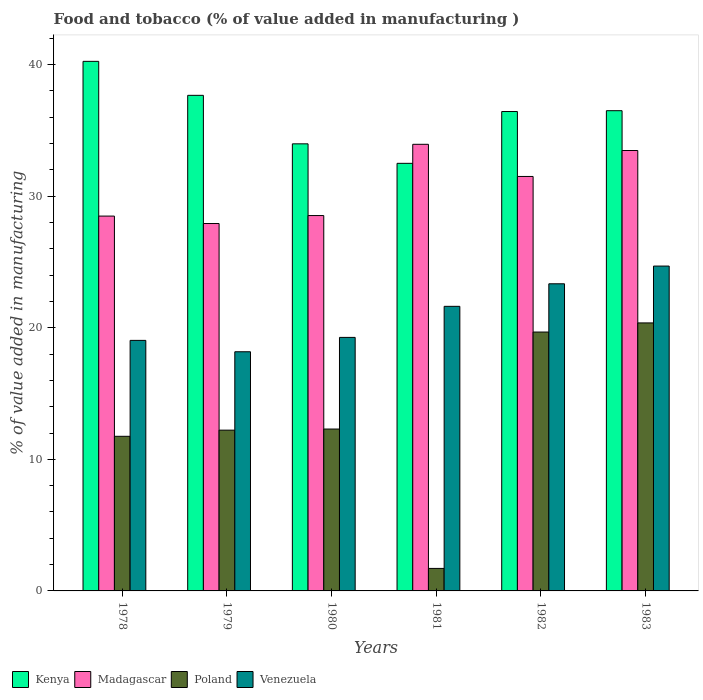How many groups of bars are there?
Keep it short and to the point. 6. Are the number of bars per tick equal to the number of legend labels?
Your answer should be compact. Yes. How many bars are there on the 6th tick from the left?
Make the answer very short. 4. What is the label of the 4th group of bars from the left?
Keep it short and to the point. 1981. In how many cases, is the number of bars for a given year not equal to the number of legend labels?
Your answer should be compact. 0. What is the value added in manufacturing food and tobacco in Kenya in 1982?
Your answer should be very brief. 36.43. Across all years, what is the maximum value added in manufacturing food and tobacco in Kenya?
Your answer should be compact. 40.25. Across all years, what is the minimum value added in manufacturing food and tobacco in Poland?
Offer a very short reply. 1.71. In which year was the value added in manufacturing food and tobacco in Kenya maximum?
Provide a short and direct response. 1978. In which year was the value added in manufacturing food and tobacco in Poland minimum?
Your answer should be compact. 1981. What is the total value added in manufacturing food and tobacco in Venezuela in the graph?
Ensure brevity in your answer.  126.14. What is the difference between the value added in manufacturing food and tobacco in Venezuela in 1978 and that in 1983?
Provide a succinct answer. -5.65. What is the difference between the value added in manufacturing food and tobacco in Venezuela in 1981 and the value added in manufacturing food and tobacco in Kenya in 1980?
Provide a succinct answer. -12.35. What is the average value added in manufacturing food and tobacco in Madagascar per year?
Your response must be concise. 30.64. In the year 1978, what is the difference between the value added in manufacturing food and tobacco in Kenya and value added in manufacturing food and tobacco in Poland?
Your answer should be very brief. 28.5. What is the ratio of the value added in manufacturing food and tobacco in Madagascar in 1978 to that in 1980?
Keep it short and to the point. 1. Is the value added in manufacturing food and tobacco in Poland in 1979 less than that in 1980?
Provide a succinct answer. Yes. What is the difference between the highest and the second highest value added in manufacturing food and tobacco in Kenya?
Offer a terse response. 2.58. What is the difference between the highest and the lowest value added in manufacturing food and tobacco in Madagascar?
Give a very brief answer. 6.02. Is it the case that in every year, the sum of the value added in manufacturing food and tobacco in Poland and value added in manufacturing food and tobacco in Venezuela is greater than the sum of value added in manufacturing food and tobacco in Madagascar and value added in manufacturing food and tobacco in Kenya?
Your response must be concise. Yes. What does the 4th bar from the left in 1979 represents?
Provide a succinct answer. Venezuela. What does the 2nd bar from the right in 1982 represents?
Your answer should be very brief. Poland. Is it the case that in every year, the sum of the value added in manufacturing food and tobacco in Madagascar and value added in manufacturing food and tobacco in Kenya is greater than the value added in manufacturing food and tobacco in Poland?
Offer a terse response. Yes. Are the values on the major ticks of Y-axis written in scientific E-notation?
Offer a very short reply. No. How many legend labels are there?
Provide a short and direct response. 4. How are the legend labels stacked?
Offer a terse response. Horizontal. What is the title of the graph?
Your response must be concise. Food and tobacco (% of value added in manufacturing ). What is the label or title of the Y-axis?
Make the answer very short. % of value added in manufacturing. What is the % of value added in manufacturing in Kenya in 1978?
Make the answer very short. 40.25. What is the % of value added in manufacturing of Madagascar in 1978?
Your answer should be compact. 28.49. What is the % of value added in manufacturing in Poland in 1978?
Your answer should be compact. 11.75. What is the % of value added in manufacturing in Venezuela in 1978?
Your answer should be very brief. 19.04. What is the % of value added in manufacturing of Kenya in 1979?
Your response must be concise. 37.66. What is the % of value added in manufacturing of Madagascar in 1979?
Keep it short and to the point. 27.92. What is the % of value added in manufacturing in Poland in 1979?
Your answer should be very brief. 12.22. What is the % of value added in manufacturing in Venezuela in 1979?
Offer a terse response. 18.18. What is the % of value added in manufacturing in Kenya in 1980?
Your answer should be compact. 33.98. What is the % of value added in manufacturing in Madagascar in 1980?
Keep it short and to the point. 28.53. What is the % of value added in manufacturing in Poland in 1980?
Give a very brief answer. 12.3. What is the % of value added in manufacturing in Venezuela in 1980?
Your response must be concise. 19.27. What is the % of value added in manufacturing in Kenya in 1981?
Your response must be concise. 32.5. What is the % of value added in manufacturing of Madagascar in 1981?
Provide a short and direct response. 33.94. What is the % of value added in manufacturing of Poland in 1981?
Ensure brevity in your answer.  1.71. What is the % of value added in manufacturing in Venezuela in 1981?
Your answer should be very brief. 21.63. What is the % of value added in manufacturing in Kenya in 1982?
Ensure brevity in your answer.  36.43. What is the % of value added in manufacturing of Madagascar in 1982?
Make the answer very short. 31.5. What is the % of value added in manufacturing in Poland in 1982?
Provide a succinct answer. 19.67. What is the % of value added in manufacturing in Venezuela in 1982?
Offer a very short reply. 23.34. What is the % of value added in manufacturing of Kenya in 1983?
Your answer should be compact. 36.5. What is the % of value added in manufacturing of Madagascar in 1983?
Your answer should be compact. 33.47. What is the % of value added in manufacturing in Poland in 1983?
Provide a short and direct response. 20.37. What is the % of value added in manufacturing in Venezuela in 1983?
Your answer should be compact. 24.69. Across all years, what is the maximum % of value added in manufacturing in Kenya?
Your answer should be compact. 40.25. Across all years, what is the maximum % of value added in manufacturing in Madagascar?
Keep it short and to the point. 33.94. Across all years, what is the maximum % of value added in manufacturing in Poland?
Your answer should be compact. 20.37. Across all years, what is the maximum % of value added in manufacturing of Venezuela?
Keep it short and to the point. 24.69. Across all years, what is the minimum % of value added in manufacturing of Kenya?
Your response must be concise. 32.5. Across all years, what is the minimum % of value added in manufacturing of Madagascar?
Give a very brief answer. 27.92. Across all years, what is the minimum % of value added in manufacturing in Poland?
Your response must be concise. 1.71. Across all years, what is the minimum % of value added in manufacturing of Venezuela?
Provide a succinct answer. 18.18. What is the total % of value added in manufacturing in Kenya in the graph?
Provide a short and direct response. 217.31. What is the total % of value added in manufacturing in Madagascar in the graph?
Give a very brief answer. 183.84. What is the total % of value added in manufacturing in Poland in the graph?
Your answer should be compact. 78.02. What is the total % of value added in manufacturing in Venezuela in the graph?
Give a very brief answer. 126.14. What is the difference between the % of value added in manufacturing in Kenya in 1978 and that in 1979?
Ensure brevity in your answer.  2.58. What is the difference between the % of value added in manufacturing of Madagascar in 1978 and that in 1979?
Your answer should be compact. 0.56. What is the difference between the % of value added in manufacturing of Poland in 1978 and that in 1979?
Provide a short and direct response. -0.47. What is the difference between the % of value added in manufacturing in Venezuela in 1978 and that in 1979?
Offer a very short reply. 0.86. What is the difference between the % of value added in manufacturing in Kenya in 1978 and that in 1980?
Give a very brief answer. 6.27. What is the difference between the % of value added in manufacturing in Madagascar in 1978 and that in 1980?
Offer a very short reply. -0.04. What is the difference between the % of value added in manufacturing in Poland in 1978 and that in 1980?
Keep it short and to the point. -0.55. What is the difference between the % of value added in manufacturing of Venezuela in 1978 and that in 1980?
Keep it short and to the point. -0.23. What is the difference between the % of value added in manufacturing in Kenya in 1978 and that in 1981?
Provide a short and direct response. 7.75. What is the difference between the % of value added in manufacturing of Madagascar in 1978 and that in 1981?
Provide a succinct answer. -5.46. What is the difference between the % of value added in manufacturing of Poland in 1978 and that in 1981?
Provide a short and direct response. 10.04. What is the difference between the % of value added in manufacturing of Venezuela in 1978 and that in 1981?
Your response must be concise. -2.59. What is the difference between the % of value added in manufacturing of Kenya in 1978 and that in 1982?
Provide a succinct answer. 3.81. What is the difference between the % of value added in manufacturing in Madagascar in 1978 and that in 1982?
Ensure brevity in your answer.  -3.01. What is the difference between the % of value added in manufacturing of Poland in 1978 and that in 1982?
Offer a terse response. -7.92. What is the difference between the % of value added in manufacturing of Venezuela in 1978 and that in 1982?
Offer a very short reply. -4.3. What is the difference between the % of value added in manufacturing of Kenya in 1978 and that in 1983?
Your answer should be compact. 3.75. What is the difference between the % of value added in manufacturing of Madagascar in 1978 and that in 1983?
Give a very brief answer. -4.98. What is the difference between the % of value added in manufacturing of Poland in 1978 and that in 1983?
Make the answer very short. -8.62. What is the difference between the % of value added in manufacturing of Venezuela in 1978 and that in 1983?
Provide a short and direct response. -5.65. What is the difference between the % of value added in manufacturing of Kenya in 1979 and that in 1980?
Make the answer very short. 3.69. What is the difference between the % of value added in manufacturing in Madagascar in 1979 and that in 1980?
Keep it short and to the point. -0.61. What is the difference between the % of value added in manufacturing in Poland in 1979 and that in 1980?
Your answer should be compact. -0.08. What is the difference between the % of value added in manufacturing in Venezuela in 1979 and that in 1980?
Your answer should be very brief. -1.09. What is the difference between the % of value added in manufacturing in Kenya in 1979 and that in 1981?
Ensure brevity in your answer.  5.17. What is the difference between the % of value added in manufacturing in Madagascar in 1979 and that in 1981?
Keep it short and to the point. -6.02. What is the difference between the % of value added in manufacturing in Poland in 1979 and that in 1981?
Your response must be concise. 10.51. What is the difference between the % of value added in manufacturing in Venezuela in 1979 and that in 1981?
Your answer should be very brief. -3.45. What is the difference between the % of value added in manufacturing in Kenya in 1979 and that in 1982?
Your answer should be compact. 1.23. What is the difference between the % of value added in manufacturing in Madagascar in 1979 and that in 1982?
Keep it short and to the point. -3.58. What is the difference between the % of value added in manufacturing in Poland in 1979 and that in 1982?
Your answer should be compact. -7.46. What is the difference between the % of value added in manufacturing of Venezuela in 1979 and that in 1982?
Ensure brevity in your answer.  -5.16. What is the difference between the % of value added in manufacturing in Kenya in 1979 and that in 1983?
Your response must be concise. 1.17. What is the difference between the % of value added in manufacturing of Madagascar in 1979 and that in 1983?
Keep it short and to the point. -5.55. What is the difference between the % of value added in manufacturing of Poland in 1979 and that in 1983?
Provide a succinct answer. -8.15. What is the difference between the % of value added in manufacturing in Venezuela in 1979 and that in 1983?
Ensure brevity in your answer.  -6.51. What is the difference between the % of value added in manufacturing of Kenya in 1980 and that in 1981?
Give a very brief answer. 1.48. What is the difference between the % of value added in manufacturing of Madagascar in 1980 and that in 1981?
Offer a terse response. -5.41. What is the difference between the % of value added in manufacturing in Poland in 1980 and that in 1981?
Make the answer very short. 10.59. What is the difference between the % of value added in manufacturing of Venezuela in 1980 and that in 1981?
Your response must be concise. -2.36. What is the difference between the % of value added in manufacturing of Kenya in 1980 and that in 1982?
Keep it short and to the point. -2.46. What is the difference between the % of value added in manufacturing in Madagascar in 1980 and that in 1982?
Ensure brevity in your answer.  -2.97. What is the difference between the % of value added in manufacturing in Poland in 1980 and that in 1982?
Your answer should be compact. -7.37. What is the difference between the % of value added in manufacturing in Venezuela in 1980 and that in 1982?
Offer a terse response. -4.07. What is the difference between the % of value added in manufacturing of Kenya in 1980 and that in 1983?
Offer a terse response. -2.52. What is the difference between the % of value added in manufacturing in Madagascar in 1980 and that in 1983?
Offer a terse response. -4.94. What is the difference between the % of value added in manufacturing in Poland in 1980 and that in 1983?
Your response must be concise. -8.07. What is the difference between the % of value added in manufacturing of Venezuela in 1980 and that in 1983?
Ensure brevity in your answer.  -5.42. What is the difference between the % of value added in manufacturing of Kenya in 1981 and that in 1982?
Give a very brief answer. -3.94. What is the difference between the % of value added in manufacturing of Madagascar in 1981 and that in 1982?
Provide a succinct answer. 2.44. What is the difference between the % of value added in manufacturing in Poland in 1981 and that in 1982?
Keep it short and to the point. -17.96. What is the difference between the % of value added in manufacturing in Venezuela in 1981 and that in 1982?
Keep it short and to the point. -1.71. What is the difference between the % of value added in manufacturing of Kenya in 1981 and that in 1983?
Make the answer very short. -4. What is the difference between the % of value added in manufacturing of Madagascar in 1981 and that in 1983?
Your answer should be compact. 0.47. What is the difference between the % of value added in manufacturing of Poland in 1981 and that in 1983?
Your answer should be very brief. -18.66. What is the difference between the % of value added in manufacturing of Venezuela in 1981 and that in 1983?
Offer a terse response. -3.06. What is the difference between the % of value added in manufacturing of Kenya in 1982 and that in 1983?
Provide a succinct answer. -0.06. What is the difference between the % of value added in manufacturing of Madagascar in 1982 and that in 1983?
Your response must be concise. -1.97. What is the difference between the % of value added in manufacturing of Poland in 1982 and that in 1983?
Your answer should be very brief. -0.69. What is the difference between the % of value added in manufacturing of Venezuela in 1982 and that in 1983?
Your answer should be very brief. -1.35. What is the difference between the % of value added in manufacturing of Kenya in 1978 and the % of value added in manufacturing of Madagascar in 1979?
Offer a terse response. 12.32. What is the difference between the % of value added in manufacturing of Kenya in 1978 and the % of value added in manufacturing of Poland in 1979?
Provide a succinct answer. 28.03. What is the difference between the % of value added in manufacturing in Kenya in 1978 and the % of value added in manufacturing in Venezuela in 1979?
Your response must be concise. 22.07. What is the difference between the % of value added in manufacturing in Madagascar in 1978 and the % of value added in manufacturing in Poland in 1979?
Make the answer very short. 16.27. What is the difference between the % of value added in manufacturing in Madagascar in 1978 and the % of value added in manufacturing in Venezuela in 1979?
Provide a succinct answer. 10.31. What is the difference between the % of value added in manufacturing in Poland in 1978 and the % of value added in manufacturing in Venezuela in 1979?
Provide a succinct answer. -6.43. What is the difference between the % of value added in manufacturing of Kenya in 1978 and the % of value added in manufacturing of Madagascar in 1980?
Offer a very short reply. 11.72. What is the difference between the % of value added in manufacturing in Kenya in 1978 and the % of value added in manufacturing in Poland in 1980?
Your answer should be compact. 27.94. What is the difference between the % of value added in manufacturing in Kenya in 1978 and the % of value added in manufacturing in Venezuela in 1980?
Ensure brevity in your answer.  20.98. What is the difference between the % of value added in manufacturing of Madagascar in 1978 and the % of value added in manufacturing of Poland in 1980?
Your response must be concise. 16.18. What is the difference between the % of value added in manufacturing of Madagascar in 1978 and the % of value added in manufacturing of Venezuela in 1980?
Make the answer very short. 9.22. What is the difference between the % of value added in manufacturing in Poland in 1978 and the % of value added in manufacturing in Venezuela in 1980?
Ensure brevity in your answer.  -7.52. What is the difference between the % of value added in manufacturing in Kenya in 1978 and the % of value added in manufacturing in Madagascar in 1981?
Offer a terse response. 6.3. What is the difference between the % of value added in manufacturing in Kenya in 1978 and the % of value added in manufacturing in Poland in 1981?
Your answer should be compact. 38.54. What is the difference between the % of value added in manufacturing of Kenya in 1978 and the % of value added in manufacturing of Venezuela in 1981?
Make the answer very short. 18.62. What is the difference between the % of value added in manufacturing in Madagascar in 1978 and the % of value added in manufacturing in Poland in 1981?
Provide a short and direct response. 26.78. What is the difference between the % of value added in manufacturing in Madagascar in 1978 and the % of value added in manufacturing in Venezuela in 1981?
Your response must be concise. 6.86. What is the difference between the % of value added in manufacturing of Poland in 1978 and the % of value added in manufacturing of Venezuela in 1981?
Your response must be concise. -9.88. What is the difference between the % of value added in manufacturing in Kenya in 1978 and the % of value added in manufacturing in Madagascar in 1982?
Offer a very short reply. 8.75. What is the difference between the % of value added in manufacturing in Kenya in 1978 and the % of value added in manufacturing in Poland in 1982?
Keep it short and to the point. 20.57. What is the difference between the % of value added in manufacturing in Kenya in 1978 and the % of value added in manufacturing in Venezuela in 1982?
Offer a terse response. 16.9. What is the difference between the % of value added in manufacturing of Madagascar in 1978 and the % of value added in manufacturing of Poland in 1982?
Your answer should be very brief. 8.81. What is the difference between the % of value added in manufacturing in Madagascar in 1978 and the % of value added in manufacturing in Venezuela in 1982?
Keep it short and to the point. 5.15. What is the difference between the % of value added in manufacturing in Poland in 1978 and the % of value added in manufacturing in Venezuela in 1982?
Your response must be concise. -11.59. What is the difference between the % of value added in manufacturing in Kenya in 1978 and the % of value added in manufacturing in Madagascar in 1983?
Provide a short and direct response. 6.78. What is the difference between the % of value added in manufacturing of Kenya in 1978 and the % of value added in manufacturing of Poland in 1983?
Your answer should be compact. 19.88. What is the difference between the % of value added in manufacturing in Kenya in 1978 and the % of value added in manufacturing in Venezuela in 1983?
Provide a succinct answer. 15.56. What is the difference between the % of value added in manufacturing in Madagascar in 1978 and the % of value added in manufacturing in Poland in 1983?
Keep it short and to the point. 8.12. What is the difference between the % of value added in manufacturing of Madagascar in 1978 and the % of value added in manufacturing of Venezuela in 1983?
Give a very brief answer. 3.8. What is the difference between the % of value added in manufacturing of Poland in 1978 and the % of value added in manufacturing of Venezuela in 1983?
Offer a terse response. -12.94. What is the difference between the % of value added in manufacturing in Kenya in 1979 and the % of value added in manufacturing in Madagascar in 1980?
Offer a very short reply. 9.14. What is the difference between the % of value added in manufacturing in Kenya in 1979 and the % of value added in manufacturing in Poland in 1980?
Provide a succinct answer. 25.36. What is the difference between the % of value added in manufacturing in Kenya in 1979 and the % of value added in manufacturing in Venezuela in 1980?
Ensure brevity in your answer.  18.4. What is the difference between the % of value added in manufacturing in Madagascar in 1979 and the % of value added in manufacturing in Poland in 1980?
Your response must be concise. 15.62. What is the difference between the % of value added in manufacturing in Madagascar in 1979 and the % of value added in manufacturing in Venezuela in 1980?
Give a very brief answer. 8.65. What is the difference between the % of value added in manufacturing in Poland in 1979 and the % of value added in manufacturing in Venezuela in 1980?
Offer a terse response. -7.05. What is the difference between the % of value added in manufacturing of Kenya in 1979 and the % of value added in manufacturing of Madagascar in 1981?
Give a very brief answer. 3.72. What is the difference between the % of value added in manufacturing of Kenya in 1979 and the % of value added in manufacturing of Poland in 1981?
Ensure brevity in your answer.  35.95. What is the difference between the % of value added in manufacturing of Kenya in 1979 and the % of value added in manufacturing of Venezuela in 1981?
Your answer should be very brief. 16.04. What is the difference between the % of value added in manufacturing of Madagascar in 1979 and the % of value added in manufacturing of Poland in 1981?
Ensure brevity in your answer.  26.21. What is the difference between the % of value added in manufacturing of Madagascar in 1979 and the % of value added in manufacturing of Venezuela in 1981?
Give a very brief answer. 6.29. What is the difference between the % of value added in manufacturing of Poland in 1979 and the % of value added in manufacturing of Venezuela in 1981?
Your answer should be compact. -9.41. What is the difference between the % of value added in manufacturing of Kenya in 1979 and the % of value added in manufacturing of Madagascar in 1982?
Offer a terse response. 6.16. What is the difference between the % of value added in manufacturing of Kenya in 1979 and the % of value added in manufacturing of Poland in 1982?
Your response must be concise. 17.99. What is the difference between the % of value added in manufacturing of Kenya in 1979 and the % of value added in manufacturing of Venezuela in 1982?
Your answer should be very brief. 14.32. What is the difference between the % of value added in manufacturing in Madagascar in 1979 and the % of value added in manufacturing in Poland in 1982?
Offer a very short reply. 8.25. What is the difference between the % of value added in manufacturing in Madagascar in 1979 and the % of value added in manufacturing in Venezuela in 1982?
Provide a short and direct response. 4.58. What is the difference between the % of value added in manufacturing of Poland in 1979 and the % of value added in manufacturing of Venezuela in 1982?
Your answer should be very brief. -11.12. What is the difference between the % of value added in manufacturing in Kenya in 1979 and the % of value added in manufacturing in Madagascar in 1983?
Provide a succinct answer. 4.19. What is the difference between the % of value added in manufacturing of Kenya in 1979 and the % of value added in manufacturing of Poland in 1983?
Your response must be concise. 17.3. What is the difference between the % of value added in manufacturing in Kenya in 1979 and the % of value added in manufacturing in Venezuela in 1983?
Provide a short and direct response. 12.97. What is the difference between the % of value added in manufacturing of Madagascar in 1979 and the % of value added in manufacturing of Poland in 1983?
Ensure brevity in your answer.  7.55. What is the difference between the % of value added in manufacturing in Madagascar in 1979 and the % of value added in manufacturing in Venezuela in 1983?
Offer a terse response. 3.23. What is the difference between the % of value added in manufacturing of Poland in 1979 and the % of value added in manufacturing of Venezuela in 1983?
Your answer should be very brief. -12.47. What is the difference between the % of value added in manufacturing in Kenya in 1980 and the % of value added in manufacturing in Madagascar in 1981?
Offer a very short reply. 0.04. What is the difference between the % of value added in manufacturing of Kenya in 1980 and the % of value added in manufacturing of Poland in 1981?
Provide a succinct answer. 32.27. What is the difference between the % of value added in manufacturing in Kenya in 1980 and the % of value added in manufacturing in Venezuela in 1981?
Your answer should be compact. 12.35. What is the difference between the % of value added in manufacturing in Madagascar in 1980 and the % of value added in manufacturing in Poland in 1981?
Provide a short and direct response. 26.82. What is the difference between the % of value added in manufacturing in Madagascar in 1980 and the % of value added in manufacturing in Venezuela in 1981?
Provide a short and direct response. 6.9. What is the difference between the % of value added in manufacturing in Poland in 1980 and the % of value added in manufacturing in Venezuela in 1981?
Give a very brief answer. -9.33. What is the difference between the % of value added in manufacturing in Kenya in 1980 and the % of value added in manufacturing in Madagascar in 1982?
Make the answer very short. 2.48. What is the difference between the % of value added in manufacturing of Kenya in 1980 and the % of value added in manufacturing of Poland in 1982?
Your response must be concise. 14.3. What is the difference between the % of value added in manufacturing in Kenya in 1980 and the % of value added in manufacturing in Venezuela in 1982?
Give a very brief answer. 10.64. What is the difference between the % of value added in manufacturing in Madagascar in 1980 and the % of value added in manufacturing in Poland in 1982?
Offer a terse response. 8.85. What is the difference between the % of value added in manufacturing of Madagascar in 1980 and the % of value added in manufacturing of Venezuela in 1982?
Provide a short and direct response. 5.19. What is the difference between the % of value added in manufacturing of Poland in 1980 and the % of value added in manufacturing of Venezuela in 1982?
Provide a short and direct response. -11.04. What is the difference between the % of value added in manufacturing of Kenya in 1980 and the % of value added in manufacturing of Madagascar in 1983?
Ensure brevity in your answer.  0.51. What is the difference between the % of value added in manufacturing in Kenya in 1980 and the % of value added in manufacturing in Poland in 1983?
Keep it short and to the point. 13.61. What is the difference between the % of value added in manufacturing in Kenya in 1980 and the % of value added in manufacturing in Venezuela in 1983?
Offer a terse response. 9.29. What is the difference between the % of value added in manufacturing of Madagascar in 1980 and the % of value added in manufacturing of Poland in 1983?
Your answer should be very brief. 8.16. What is the difference between the % of value added in manufacturing in Madagascar in 1980 and the % of value added in manufacturing in Venezuela in 1983?
Your response must be concise. 3.84. What is the difference between the % of value added in manufacturing of Poland in 1980 and the % of value added in manufacturing of Venezuela in 1983?
Give a very brief answer. -12.39. What is the difference between the % of value added in manufacturing of Kenya in 1981 and the % of value added in manufacturing of Madagascar in 1982?
Offer a very short reply. 1. What is the difference between the % of value added in manufacturing in Kenya in 1981 and the % of value added in manufacturing in Poland in 1982?
Your answer should be very brief. 12.82. What is the difference between the % of value added in manufacturing in Kenya in 1981 and the % of value added in manufacturing in Venezuela in 1982?
Ensure brevity in your answer.  9.15. What is the difference between the % of value added in manufacturing of Madagascar in 1981 and the % of value added in manufacturing of Poland in 1982?
Make the answer very short. 14.27. What is the difference between the % of value added in manufacturing in Madagascar in 1981 and the % of value added in manufacturing in Venezuela in 1982?
Offer a terse response. 10.6. What is the difference between the % of value added in manufacturing of Poland in 1981 and the % of value added in manufacturing of Venezuela in 1982?
Your answer should be very brief. -21.63. What is the difference between the % of value added in manufacturing of Kenya in 1981 and the % of value added in manufacturing of Madagascar in 1983?
Offer a terse response. -0.98. What is the difference between the % of value added in manufacturing in Kenya in 1981 and the % of value added in manufacturing in Poland in 1983?
Provide a succinct answer. 12.13. What is the difference between the % of value added in manufacturing of Kenya in 1981 and the % of value added in manufacturing of Venezuela in 1983?
Give a very brief answer. 7.81. What is the difference between the % of value added in manufacturing of Madagascar in 1981 and the % of value added in manufacturing of Poland in 1983?
Provide a succinct answer. 13.57. What is the difference between the % of value added in manufacturing of Madagascar in 1981 and the % of value added in manufacturing of Venezuela in 1983?
Offer a very short reply. 9.25. What is the difference between the % of value added in manufacturing of Poland in 1981 and the % of value added in manufacturing of Venezuela in 1983?
Provide a succinct answer. -22.98. What is the difference between the % of value added in manufacturing in Kenya in 1982 and the % of value added in manufacturing in Madagascar in 1983?
Offer a terse response. 2.96. What is the difference between the % of value added in manufacturing of Kenya in 1982 and the % of value added in manufacturing of Poland in 1983?
Offer a terse response. 16.07. What is the difference between the % of value added in manufacturing of Kenya in 1982 and the % of value added in manufacturing of Venezuela in 1983?
Keep it short and to the point. 11.75. What is the difference between the % of value added in manufacturing of Madagascar in 1982 and the % of value added in manufacturing of Poland in 1983?
Give a very brief answer. 11.13. What is the difference between the % of value added in manufacturing in Madagascar in 1982 and the % of value added in manufacturing in Venezuela in 1983?
Offer a terse response. 6.81. What is the difference between the % of value added in manufacturing in Poland in 1982 and the % of value added in manufacturing in Venezuela in 1983?
Provide a short and direct response. -5.01. What is the average % of value added in manufacturing of Kenya per year?
Offer a terse response. 36.22. What is the average % of value added in manufacturing in Madagascar per year?
Your answer should be compact. 30.64. What is the average % of value added in manufacturing of Poland per year?
Your answer should be very brief. 13. What is the average % of value added in manufacturing of Venezuela per year?
Your response must be concise. 21.02. In the year 1978, what is the difference between the % of value added in manufacturing of Kenya and % of value added in manufacturing of Madagascar?
Your answer should be very brief. 11.76. In the year 1978, what is the difference between the % of value added in manufacturing in Kenya and % of value added in manufacturing in Poland?
Give a very brief answer. 28.5. In the year 1978, what is the difference between the % of value added in manufacturing of Kenya and % of value added in manufacturing of Venezuela?
Provide a short and direct response. 21.21. In the year 1978, what is the difference between the % of value added in manufacturing of Madagascar and % of value added in manufacturing of Poland?
Your answer should be very brief. 16.74. In the year 1978, what is the difference between the % of value added in manufacturing in Madagascar and % of value added in manufacturing in Venezuela?
Your answer should be very brief. 9.45. In the year 1978, what is the difference between the % of value added in manufacturing of Poland and % of value added in manufacturing of Venezuela?
Your answer should be very brief. -7.29. In the year 1979, what is the difference between the % of value added in manufacturing in Kenya and % of value added in manufacturing in Madagascar?
Offer a terse response. 9.74. In the year 1979, what is the difference between the % of value added in manufacturing of Kenya and % of value added in manufacturing of Poland?
Ensure brevity in your answer.  25.44. In the year 1979, what is the difference between the % of value added in manufacturing in Kenya and % of value added in manufacturing in Venezuela?
Your response must be concise. 19.49. In the year 1979, what is the difference between the % of value added in manufacturing of Madagascar and % of value added in manufacturing of Poland?
Your answer should be very brief. 15.7. In the year 1979, what is the difference between the % of value added in manufacturing in Madagascar and % of value added in manufacturing in Venezuela?
Your response must be concise. 9.75. In the year 1979, what is the difference between the % of value added in manufacturing of Poland and % of value added in manufacturing of Venezuela?
Offer a very short reply. -5.96. In the year 1980, what is the difference between the % of value added in manufacturing of Kenya and % of value added in manufacturing of Madagascar?
Provide a succinct answer. 5.45. In the year 1980, what is the difference between the % of value added in manufacturing in Kenya and % of value added in manufacturing in Poland?
Provide a succinct answer. 21.68. In the year 1980, what is the difference between the % of value added in manufacturing in Kenya and % of value added in manufacturing in Venezuela?
Your answer should be compact. 14.71. In the year 1980, what is the difference between the % of value added in manufacturing of Madagascar and % of value added in manufacturing of Poland?
Offer a terse response. 16.22. In the year 1980, what is the difference between the % of value added in manufacturing of Madagascar and % of value added in manufacturing of Venezuela?
Your response must be concise. 9.26. In the year 1980, what is the difference between the % of value added in manufacturing of Poland and % of value added in manufacturing of Venezuela?
Your answer should be very brief. -6.97. In the year 1981, what is the difference between the % of value added in manufacturing of Kenya and % of value added in manufacturing of Madagascar?
Offer a terse response. -1.45. In the year 1981, what is the difference between the % of value added in manufacturing of Kenya and % of value added in manufacturing of Poland?
Make the answer very short. 30.79. In the year 1981, what is the difference between the % of value added in manufacturing of Kenya and % of value added in manufacturing of Venezuela?
Your answer should be compact. 10.87. In the year 1981, what is the difference between the % of value added in manufacturing in Madagascar and % of value added in manufacturing in Poland?
Offer a terse response. 32.23. In the year 1981, what is the difference between the % of value added in manufacturing in Madagascar and % of value added in manufacturing in Venezuela?
Ensure brevity in your answer.  12.31. In the year 1981, what is the difference between the % of value added in manufacturing in Poland and % of value added in manufacturing in Venezuela?
Provide a succinct answer. -19.92. In the year 1982, what is the difference between the % of value added in manufacturing in Kenya and % of value added in manufacturing in Madagascar?
Your answer should be compact. 4.94. In the year 1982, what is the difference between the % of value added in manufacturing in Kenya and % of value added in manufacturing in Poland?
Provide a succinct answer. 16.76. In the year 1982, what is the difference between the % of value added in manufacturing in Kenya and % of value added in manufacturing in Venezuela?
Offer a very short reply. 13.09. In the year 1982, what is the difference between the % of value added in manufacturing of Madagascar and % of value added in manufacturing of Poland?
Offer a terse response. 11.82. In the year 1982, what is the difference between the % of value added in manufacturing of Madagascar and % of value added in manufacturing of Venezuela?
Ensure brevity in your answer.  8.16. In the year 1982, what is the difference between the % of value added in manufacturing of Poland and % of value added in manufacturing of Venezuela?
Keep it short and to the point. -3.67. In the year 1983, what is the difference between the % of value added in manufacturing of Kenya and % of value added in manufacturing of Madagascar?
Provide a succinct answer. 3.02. In the year 1983, what is the difference between the % of value added in manufacturing of Kenya and % of value added in manufacturing of Poland?
Offer a very short reply. 16.13. In the year 1983, what is the difference between the % of value added in manufacturing in Kenya and % of value added in manufacturing in Venezuela?
Your answer should be compact. 11.81. In the year 1983, what is the difference between the % of value added in manufacturing in Madagascar and % of value added in manufacturing in Poland?
Provide a succinct answer. 13.1. In the year 1983, what is the difference between the % of value added in manufacturing in Madagascar and % of value added in manufacturing in Venezuela?
Provide a short and direct response. 8.78. In the year 1983, what is the difference between the % of value added in manufacturing in Poland and % of value added in manufacturing in Venezuela?
Your answer should be compact. -4.32. What is the ratio of the % of value added in manufacturing of Kenya in 1978 to that in 1979?
Your answer should be very brief. 1.07. What is the ratio of the % of value added in manufacturing in Madagascar in 1978 to that in 1979?
Provide a short and direct response. 1.02. What is the ratio of the % of value added in manufacturing in Poland in 1978 to that in 1979?
Your response must be concise. 0.96. What is the ratio of the % of value added in manufacturing in Venezuela in 1978 to that in 1979?
Offer a terse response. 1.05. What is the ratio of the % of value added in manufacturing of Kenya in 1978 to that in 1980?
Keep it short and to the point. 1.18. What is the ratio of the % of value added in manufacturing of Poland in 1978 to that in 1980?
Offer a very short reply. 0.96. What is the ratio of the % of value added in manufacturing in Kenya in 1978 to that in 1981?
Your answer should be very brief. 1.24. What is the ratio of the % of value added in manufacturing in Madagascar in 1978 to that in 1981?
Your answer should be compact. 0.84. What is the ratio of the % of value added in manufacturing of Poland in 1978 to that in 1981?
Give a very brief answer. 6.87. What is the ratio of the % of value added in manufacturing in Venezuela in 1978 to that in 1981?
Your answer should be compact. 0.88. What is the ratio of the % of value added in manufacturing in Kenya in 1978 to that in 1982?
Keep it short and to the point. 1.1. What is the ratio of the % of value added in manufacturing of Madagascar in 1978 to that in 1982?
Offer a terse response. 0.9. What is the ratio of the % of value added in manufacturing of Poland in 1978 to that in 1982?
Give a very brief answer. 0.6. What is the ratio of the % of value added in manufacturing of Venezuela in 1978 to that in 1982?
Your answer should be very brief. 0.82. What is the ratio of the % of value added in manufacturing of Kenya in 1978 to that in 1983?
Keep it short and to the point. 1.1. What is the ratio of the % of value added in manufacturing of Madagascar in 1978 to that in 1983?
Provide a short and direct response. 0.85. What is the ratio of the % of value added in manufacturing of Poland in 1978 to that in 1983?
Your answer should be compact. 0.58. What is the ratio of the % of value added in manufacturing of Venezuela in 1978 to that in 1983?
Your response must be concise. 0.77. What is the ratio of the % of value added in manufacturing in Kenya in 1979 to that in 1980?
Your answer should be compact. 1.11. What is the ratio of the % of value added in manufacturing in Madagascar in 1979 to that in 1980?
Your answer should be compact. 0.98. What is the ratio of the % of value added in manufacturing in Poland in 1979 to that in 1980?
Your response must be concise. 0.99. What is the ratio of the % of value added in manufacturing of Venezuela in 1979 to that in 1980?
Offer a very short reply. 0.94. What is the ratio of the % of value added in manufacturing in Kenya in 1979 to that in 1981?
Your answer should be compact. 1.16. What is the ratio of the % of value added in manufacturing of Madagascar in 1979 to that in 1981?
Your answer should be compact. 0.82. What is the ratio of the % of value added in manufacturing of Poland in 1979 to that in 1981?
Make the answer very short. 7.14. What is the ratio of the % of value added in manufacturing in Venezuela in 1979 to that in 1981?
Your answer should be compact. 0.84. What is the ratio of the % of value added in manufacturing of Kenya in 1979 to that in 1982?
Offer a very short reply. 1.03. What is the ratio of the % of value added in manufacturing in Madagascar in 1979 to that in 1982?
Give a very brief answer. 0.89. What is the ratio of the % of value added in manufacturing in Poland in 1979 to that in 1982?
Make the answer very short. 0.62. What is the ratio of the % of value added in manufacturing in Venezuela in 1979 to that in 1982?
Your response must be concise. 0.78. What is the ratio of the % of value added in manufacturing of Kenya in 1979 to that in 1983?
Provide a short and direct response. 1.03. What is the ratio of the % of value added in manufacturing of Madagascar in 1979 to that in 1983?
Give a very brief answer. 0.83. What is the ratio of the % of value added in manufacturing in Poland in 1979 to that in 1983?
Your response must be concise. 0.6. What is the ratio of the % of value added in manufacturing in Venezuela in 1979 to that in 1983?
Your answer should be very brief. 0.74. What is the ratio of the % of value added in manufacturing in Kenya in 1980 to that in 1981?
Give a very brief answer. 1.05. What is the ratio of the % of value added in manufacturing of Madagascar in 1980 to that in 1981?
Provide a succinct answer. 0.84. What is the ratio of the % of value added in manufacturing of Poland in 1980 to that in 1981?
Offer a terse response. 7.19. What is the ratio of the % of value added in manufacturing in Venezuela in 1980 to that in 1981?
Give a very brief answer. 0.89. What is the ratio of the % of value added in manufacturing in Kenya in 1980 to that in 1982?
Your answer should be very brief. 0.93. What is the ratio of the % of value added in manufacturing in Madagascar in 1980 to that in 1982?
Provide a short and direct response. 0.91. What is the ratio of the % of value added in manufacturing in Poland in 1980 to that in 1982?
Your answer should be very brief. 0.63. What is the ratio of the % of value added in manufacturing in Venezuela in 1980 to that in 1982?
Ensure brevity in your answer.  0.83. What is the ratio of the % of value added in manufacturing of Kenya in 1980 to that in 1983?
Make the answer very short. 0.93. What is the ratio of the % of value added in manufacturing of Madagascar in 1980 to that in 1983?
Offer a very short reply. 0.85. What is the ratio of the % of value added in manufacturing of Poland in 1980 to that in 1983?
Give a very brief answer. 0.6. What is the ratio of the % of value added in manufacturing of Venezuela in 1980 to that in 1983?
Ensure brevity in your answer.  0.78. What is the ratio of the % of value added in manufacturing in Kenya in 1981 to that in 1982?
Provide a succinct answer. 0.89. What is the ratio of the % of value added in manufacturing in Madagascar in 1981 to that in 1982?
Provide a succinct answer. 1.08. What is the ratio of the % of value added in manufacturing in Poland in 1981 to that in 1982?
Your response must be concise. 0.09. What is the ratio of the % of value added in manufacturing of Venezuela in 1981 to that in 1982?
Offer a very short reply. 0.93. What is the ratio of the % of value added in manufacturing in Kenya in 1981 to that in 1983?
Provide a succinct answer. 0.89. What is the ratio of the % of value added in manufacturing of Madagascar in 1981 to that in 1983?
Offer a terse response. 1.01. What is the ratio of the % of value added in manufacturing in Poland in 1981 to that in 1983?
Offer a terse response. 0.08. What is the ratio of the % of value added in manufacturing of Venezuela in 1981 to that in 1983?
Provide a succinct answer. 0.88. What is the ratio of the % of value added in manufacturing in Madagascar in 1982 to that in 1983?
Ensure brevity in your answer.  0.94. What is the ratio of the % of value added in manufacturing of Venezuela in 1982 to that in 1983?
Offer a terse response. 0.95. What is the difference between the highest and the second highest % of value added in manufacturing of Kenya?
Your answer should be compact. 2.58. What is the difference between the highest and the second highest % of value added in manufacturing in Madagascar?
Offer a very short reply. 0.47. What is the difference between the highest and the second highest % of value added in manufacturing in Poland?
Your answer should be very brief. 0.69. What is the difference between the highest and the second highest % of value added in manufacturing of Venezuela?
Provide a short and direct response. 1.35. What is the difference between the highest and the lowest % of value added in manufacturing of Kenya?
Keep it short and to the point. 7.75. What is the difference between the highest and the lowest % of value added in manufacturing in Madagascar?
Ensure brevity in your answer.  6.02. What is the difference between the highest and the lowest % of value added in manufacturing in Poland?
Make the answer very short. 18.66. What is the difference between the highest and the lowest % of value added in manufacturing of Venezuela?
Make the answer very short. 6.51. 